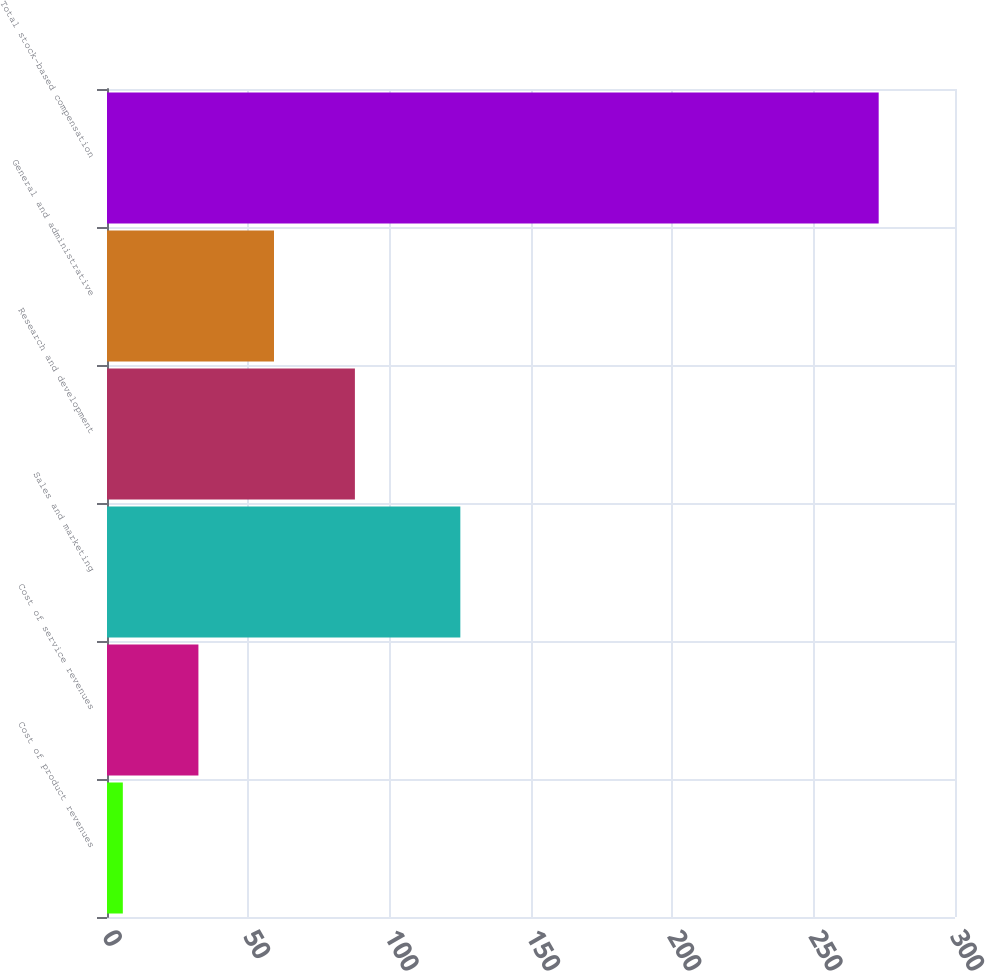Convert chart to OTSL. <chart><loc_0><loc_0><loc_500><loc_500><bar_chart><fcel>Cost of product revenues<fcel>Cost of service revenues<fcel>Sales and marketing<fcel>Research and development<fcel>General and administrative<fcel>Total stock-based compensation<nl><fcel>5.6<fcel>32.34<fcel>125<fcel>87.7<fcel>59.08<fcel>273<nl></chart> 